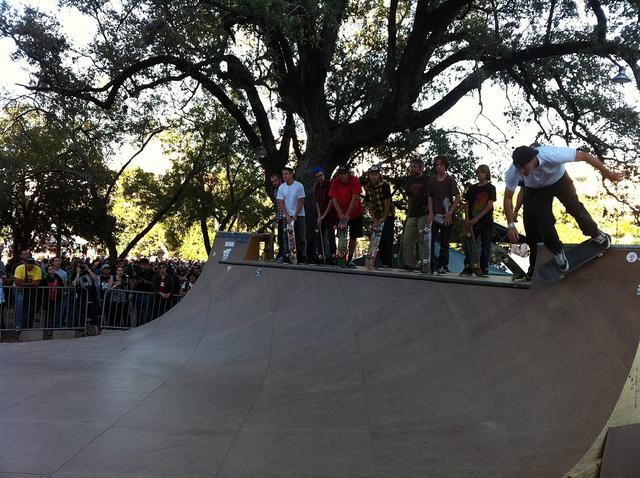How many people are on the ramp? ten 